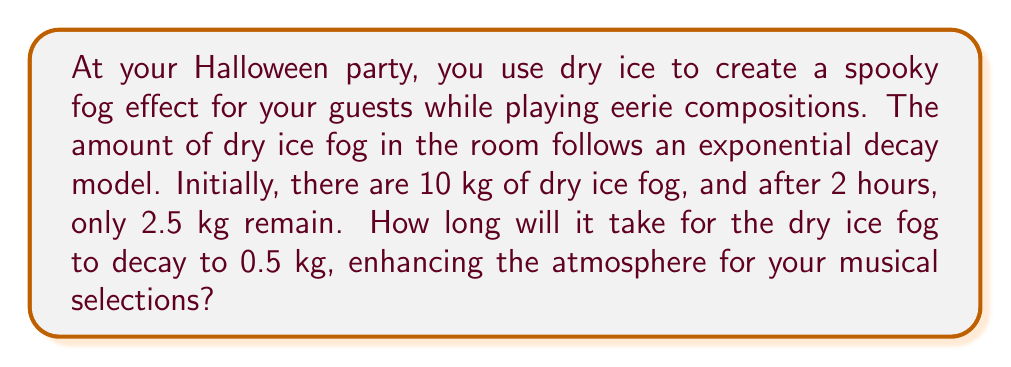Give your solution to this math problem. Let's solve this step-by-step:

1) The exponential decay model is given by the equation:
   $A(t) = A_0 \cdot e^{-kt}$
   where $A(t)$ is the amount at time $t$, $A_0$ is the initial amount, and $k$ is the decay constant.

2) We know:
   $A_0 = 10$ kg
   $A(2) = 2.5$ kg
   We need to find $k$ first.

3) Plug in the known values:
   $2.5 = 10 \cdot e^{-2k}$

4) Divide both sides by 10:
   $0.25 = e^{-2k}$

5) Take the natural log of both sides:
   $\ln(0.25) = -2k$

6) Solve for $k$:
   $k = -\frac{\ln(0.25)}{2} \approx 0.6931$

7) Now we have the full model:
   $A(t) = 10 \cdot e^{-0.6931t}$

8) To find when the fog decays to 0.5 kg, we solve:
   $0.5 = 10 \cdot e^{-0.6931t}$

9) Divide both sides by 10:
   $0.05 = e^{-0.6931t}$

10) Take the natural log of both sides:
    $\ln(0.05) = -0.6931t$

11) Solve for $t$:
    $t = -\frac{\ln(0.05)}{0.6931} \approx 4.33$ hours
Answer: 4.33 hours 